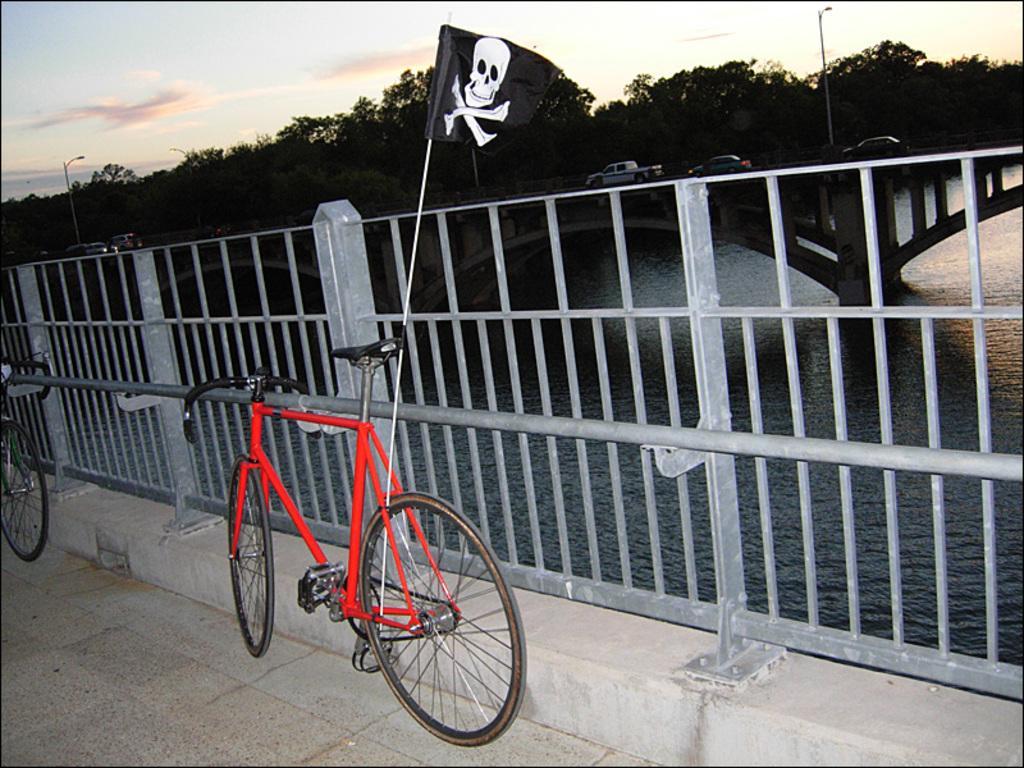How would you summarize this image in a sentence or two? In this image we can see bicycles parked on the footpath beside the fence. We can also see the pirates flag attached to a bicycle. On the backside we can see a water body and some vehicles on the bridge. We can also see a group of trees, street lights and the sky which looks cloudy. 